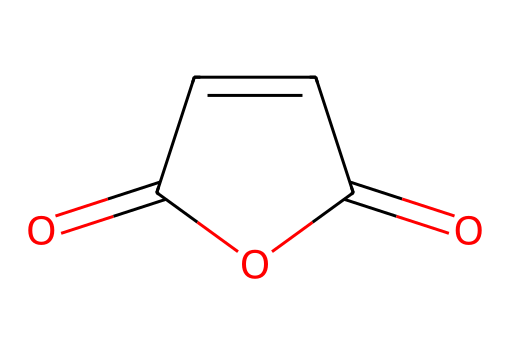What is the molecular formula of maleic anhydride? To determine the molecular formula, we count each type of atom in the structure. There are 4 carbon (C) atoms, 2 oxygen (O) atoms, and 4 hydrogen (H) atoms in the structure. Therefore, the molecular formula is C4H2O3.
Answer: C4H2O3 How many double bonds are present in this molecule? By examining the structure, we can identify that there are two double bonds: one between the carbonyl carbon and the oxygen, and the other between two carbon atoms in the ring. Thus, there are 2 double bonds.
Answer: 2 What type of functional groups are present in maleic anhydride? In the structure, we can identify the presence of anhydride functional groups characterized by the carbonyl (C=O) groups adjacent to each other and a cyclic arrangement. Thus, maleic anhydride contains an anhydride functional group.
Answer: anhydride How many carbon atoms in maleic anhydride are involved in the ring structure? Upon analyzing the structure, we can see that there are 4 total carbon atoms, of which 4 are part of the cyclic arrangement of the anhydride, indicating that all carbon atoms are part of the ring structure.
Answer: 4 What type of reaction does maleic anhydride typically undergo to form polyester resins? Maleic anhydride commonly undergoes polymerization reactions, particularly with compounds possessing hydroxyl groups, to create cross-linked structures essential in forming polyester resins.
Answer: polymerization What is the total number of atoms in maleic anhydride? To find the total atom count, we sum the atoms of each element in the molecular formula. There are 4 carbon, 2 oxygen, and 4 hydrogen atoms, which gives a total of 10 atoms.
Answer: 10 